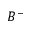<formula> <loc_0><loc_0><loc_500><loc_500>B ^ { - }</formula> 